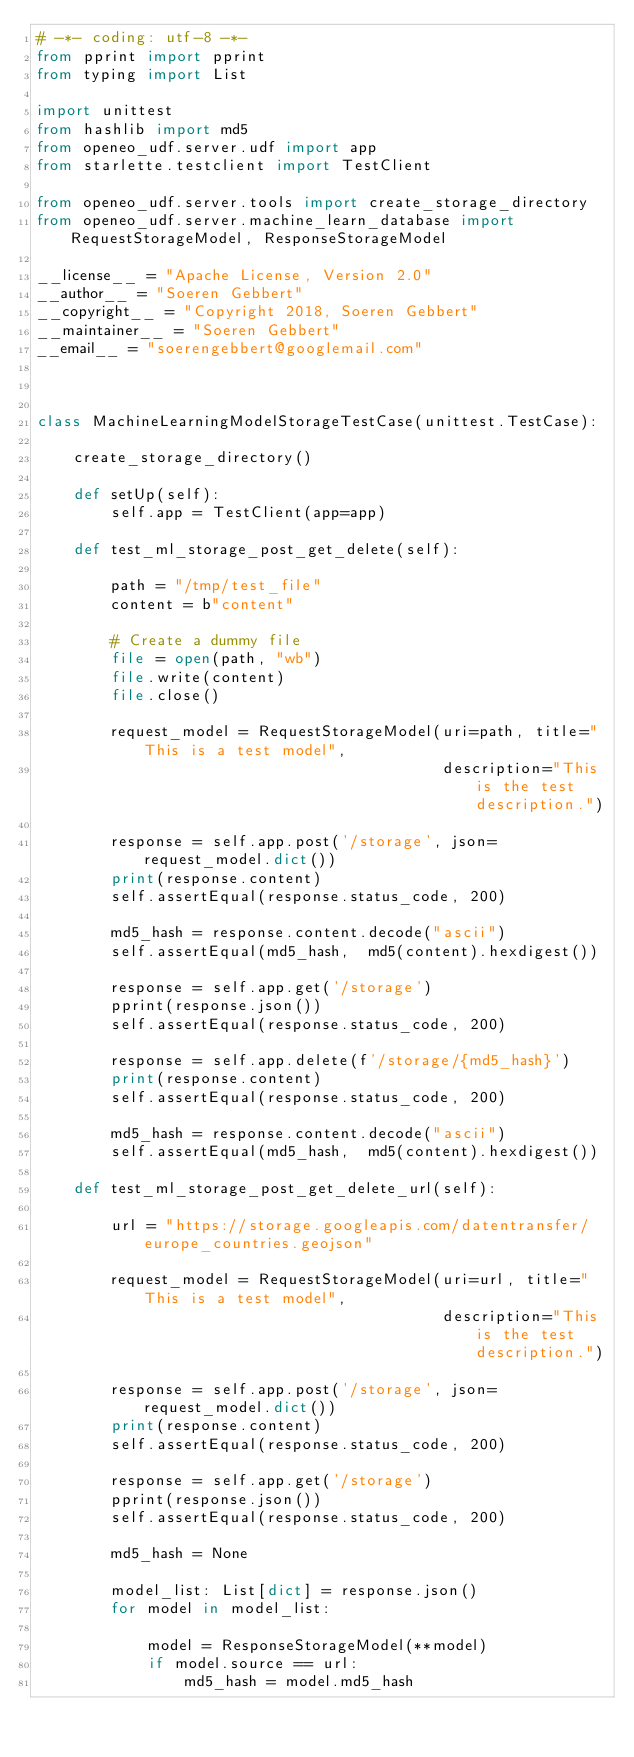<code> <loc_0><loc_0><loc_500><loc_500><_Python_># -*- coding: utf-8 -*-
from pprint import pprint
from typing import List

import unittest
from hashlib import md5
from openeo_udf.server.udf import app
from starlette.testclient import TestClient

from openeo_udf.server.tools import create_storage_directory
from openeo_udf.server.machine_learn_database import RequestStorageModel, ResponseStorageModel

__license__ = "Apache License, Version 2.0"
__author__ = "Soeren Gebbert"
__copyright__ = "Copyright 2018, Soeren Gebbert"
__maintainer__ = "Soeren Gebbert"
__email__ = "soerengebbert@googlemail.com"



class MachineLearningModelStorageTestCase(unittest.TestCase):

    create_storage_directory()

    def setUp(self):
        self.app = TestClient(app=app)

    def test_ml_storage_post_get_delete(self):

        path = "/tmp/test_file"
        content = b"content"

        # Create a dummy file
        file = open(path, "wb")
        file.write(content)
        file.close()

        request_model = RequestStorageModel(uri=path, title="This is a test model",
                                            description="This is the test description.")

        response = self.app.post('/storage', json=request_model.dict())
        print(response.content)
        self.assertEqual(response.status_code, 200)

        md5_hash = response.content.decode("ascii")
        self.assertEqual(md5_hash,  md5(content).hexdigest())

        response = self.app.get('/storage')
        pprint(response.json())
        self.assertEqual(response.status_code, 200)

        response = self.app.delete(f'/storage/{md5_hash}')
        print(response.content)
        self.assertEqual(response.status_code, 200)

        md5_hash = response.content.decode("ascii")
        self.assertEqual(md5_hash,  md5(content).hexdigest())

    def test_ml_storage_post_get_delete_url(self):

        url = "https://storage.googleapis.com/datentransfer/europe_countries.geojson"

        request_model = RequestStorageModel(uri=url, title="This is a test model",
                                            description="This is the test description.")

        response = self.app.post('/storage', json=request_model.dict())
        print(response.content)
        self.assertEqual(response.status_code, 200)

        response = self.app.get('/storage')
        pprint(response.json())
        self.assertEqual(response.status_code, 200)

        md5_hash = None

        model_list: List[dict] = response.json()
        for model in model_list:

            model = ResponseStorageModel(**model)
            if model.source == url:
                md5_hash = model.md5_hash
</code> 